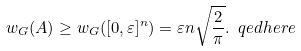Convert formula to latex. <formula><loc_0><loc_0><loc_500><loc_500>w _ { G } ( A ) \geq w _ { G } ( [ 0 , \varepsilon ] ^ { n } ) = \varepsilon n \sqrt { \frac { 2 } { \pi } } . \ q e d h e r e</formula> 